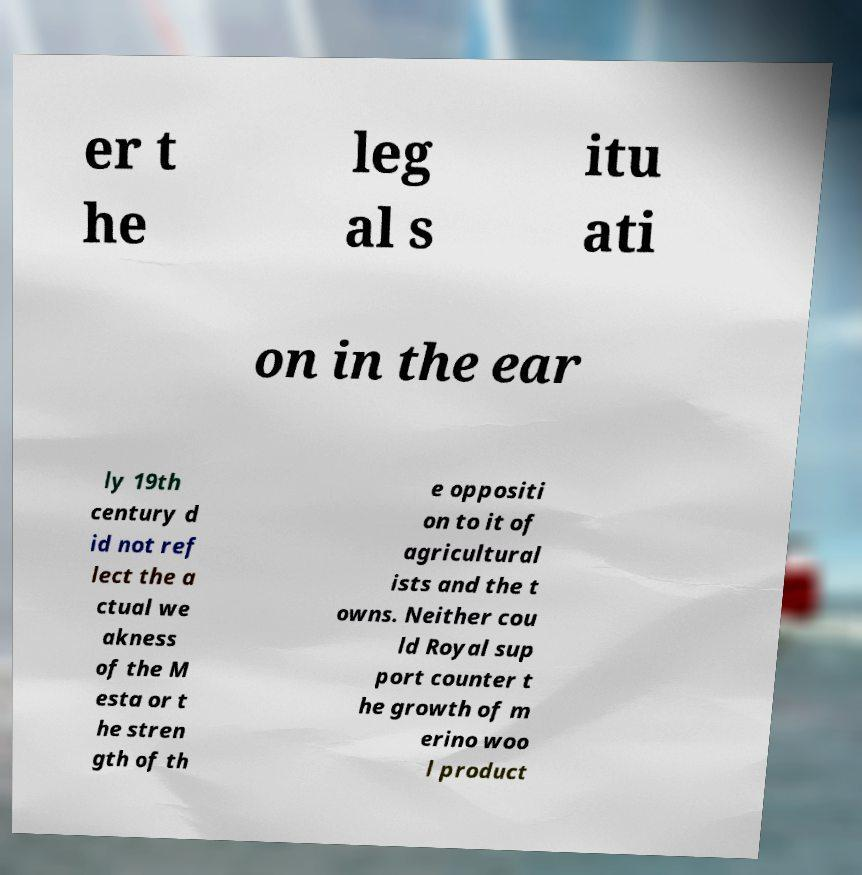Please read and relay the text visible in this image. What does it say? er t he leg al s itu ati on in the ear ly 19th century d id not ref lect the a ctual we akness of the M esta or t he stren gth of th e oppositi on to it of agricultural ists and the t owns. Neither cou ld Royal sup port counter t he growth of m erino woo l product 